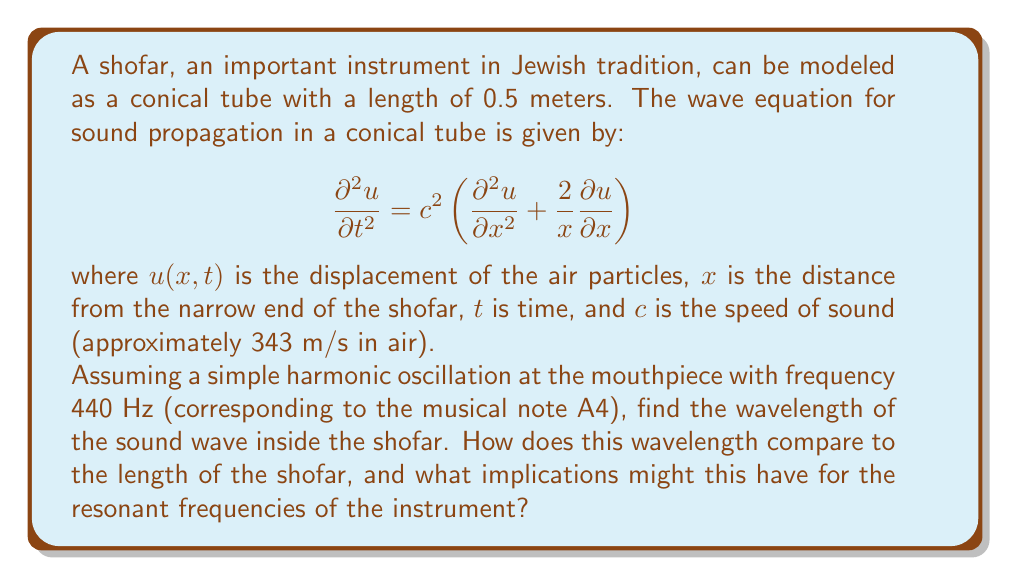Give your solution to this math problem. To solve this problem, we'll follow these steps:

1) First, we need to recall the relationship between frequency ($f$), wavelength ($\lambda$), and wave speed ($c$):

   $$c = f\lambda$$

2) We're given the frequency $f = 440$ Hz and the speed of sound $c = 343$ m/s. Let's substitute these into the equation:

   $$343 = 440\lambda$$

3) Solving for $\lambda$:

   $$\lambda = \frac{343}{440} \approx 0.78\text{ meters}$$

4) Now, let's compare this to the length of the shofar (0.5 meters):

   $$\frac{\text{Wavelength}}{\text{Shofar length}} = \frac{0.78}{0.5} \approx 1.56$$

5) This means that the wavelength is about 1.56 times the length of the shofar.

6) In terms of implications for resonant frequencies:

   - The fundamental frequency of a conical tube open at one end (like a shofar) occurs when the wavelength is about 4 times the length of the tube.
   - Higher harmonics occur at odd multiples of this fundamental frequency.
   - Since our calculated wavelength is less than 4 times the length of the shofar, this particular frequency (440 Hz) is likely to be a higher harmonic rather than the fundamental frequency.
   - The actual fundamental frequency of the shofar would be lower than 440 Hz, and 440 Hz might correspond to the 3rd or 5th harmonic, depending on the exact shape of the shofar.

This analysis helps explain why the shofar produces its characteristic rich, complex tone, which is significant in its ritual use in Jewish traditions, particularly during Rosh Hashanah and Yom Kippur.
Answer: The wavelength of the 440 Hz sound wave in the shofar is approximately 0.78 meters, which is about 1.56 times the length of the shofar. This suggests that 440 Hz is likely a higher harmonic of the shofar's fundamental frequency, contributing to its complex tonal quality. 